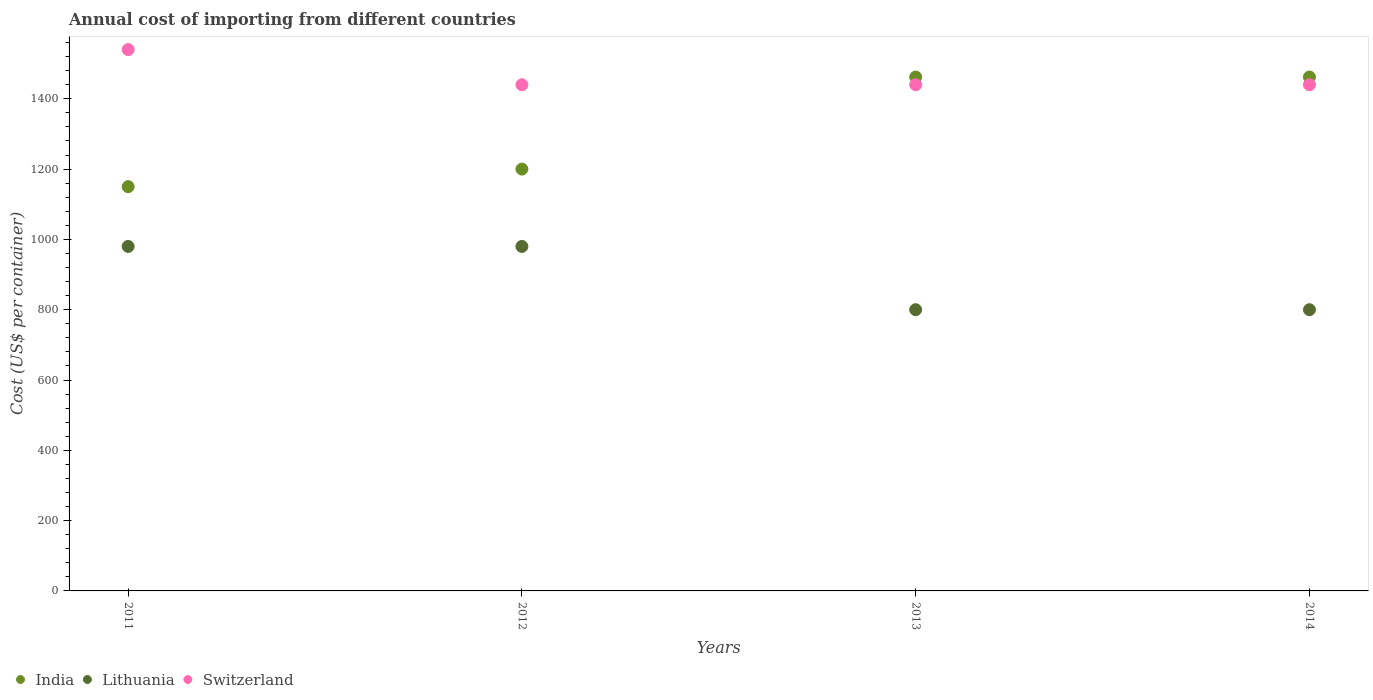How many different coloured dotlines are there?
Keep it short and to the point. 3. Is the number of dotlines equal to the number of legend labels?
Offer a very short reply. Yes. What is the total annual cost of importing in Switzerland in 2014?
Your answer should be compact. 1440. Across all years, what is the maximum total annual cost of importing in Switzerland?
Provide a succinct answer. 1540. Across all years, what is the minimum total annual cost of importing in Switzerland?
Make the answer very short. 1440. In which year was the total annual cost of importing in Switzerland minimum?
Your response must be concise. 2012. What is the total total annual cost of importing in India in the graph?
Make the answer very short. 5274. What is the difference between the total annual cost of importing in India in 2013 and that in 2014?
Provide a succinct answer. 0. What is the difference between the total annual cost of importing in Switzerland in 2011 and the total annual cost of importing in Lithuania in 2014?
Offer a terse response. 740. What is the average total annual cost of importing in Lithuania per year?
Your answer should be very brief. 890. In the year 2014, what is the difference between the total annual cost of importing in India and total annual cost of importing in Switzerland?
Offer a very short reply. 22. What is the ratio of the total annual cost of importing in Lithuania in 2013 to that in 2014?
Offer a terse response. 1. Is the total annual cost of importing in Switzerland in 2012 less than that in 2014?
Your answer should be very brief. No. Is the difference between the total annual cost of importing in India in 2011 and 2012 greater than the difference between the total annual cost of importing in Switzerland in 2011 and 2012?
Offer a terse response. No. What is the difference between the highest and the second highest total annual cost of importing in India?
Provide a succinct answer. 0. What is the difference between the highest and the lowest total annual cost of importing in Switzerland?
Make the answer very short. 100. Is the total annual cost of importing in Switzerland strictly less than the total annual cost of importing in Lithuania over the years?
Keep it short and to the point. No. How many dotlines are there?
Provide a short and direct response. 3. What is the difference between two consecutive major ticks on the Y-axis?
Provide a short and direct response. 200. Does the graph contain grids?
Offer a terse response. No. Where does the legend appear in the graph?
Your response must be concise. Bottom left. How are the legend labels stacked?
Offer a very short reply. Horizontal. What is the title of the graph?
Keep it short and to the point. Annual cost of importing from different countries. Does "Pakistan" appear as one of the legend labels in the graph?
Ensure brevity in your answer.  No. What is the label or title of the X-axis?
Your answer should be compact. Years. What is the label or title of the Y-axis?
Your answer should be very brief. Cost (US$ per container). What is the Cost (US$ per container) of India in 2011?
Give a very brief answer. 1150. What is the Cost (US$ per container) of Lithuania in 2011?
Your response must be concise. 980. What is the Cost (US$ per container) in Switzerland in 2011?
Your response must be concise. 1540. What is the Cost (US$ per container) in India in 2012?
Offer a terse response. 1200. What is the Cost (US$ per container) of Lithuania in 2012?
Offer a very short reply. 980. What is the Cost (US$ per container) of Switzerland in 2012?
Provide a short and direct response. 1440. What is the Cost (US$ per container) in India in 2013?
Your response must be concise. 1462. What is the Cost (US$ per container) in Lithuania in 2013?
Your answer should be very brief. 800. What is the Cost (US$ per container) of Switzerland in 2013?
Your answer should be compact. 1440. What is the Cost (US$ per container) of India in 2014?
Offer a terse response. 1462. What is the Cost (US$ per container) in Lithuania in 2014?
Give a very brief answer. 800. What is the Cost (US$ per container) in Switzerland in 2014?
Offer a very short reply. 1440. Across all years, what is the maximum Cost (US$ per container) of India?
Give a very brief answer. 1462. Across all years, what is the maximum Cost (US$ per container) in Lithuania?
Your response must be concise. 980. Across all years, what is the maximum Cost (US$ per container) in Switzerland?
Offer a terse response. 1540. Across all years, what is the minimum Cost (US$ per container) in India?
Provide a short and direct response. 1150. Across all years, what is the minimum Cost (US$ per container) in Lithuania?
Offer a very short reply. 800. Across all years, what is the minimum Cost (US$ per container) of Switzerland?
Your answer should be very brief. 1440. What is the total Cost (US$ per container) of India in the graph?
Your answer should be compact. 5274. What is the total Cost (US$ per container) of Lithuania in the graph?
Give a very brief answer. 3560. What is the total Cost (US$ per container) in Switzerland in the graph?
Your answer should be compact. 5860. What is the difference between the Cost (US$ per container) in Lithuania in 2011 and that in 2012?
Make the answer very short. 0. What is the difference between the Cost (US$ per container) of India in 2011 and that in 2013?
Your answer should be very brief. -312. What is the difference between the Cost (US$ per container) in Lithuania in 2011 and that in 2013?
Offer a very short reply. 180. What is the difference between the Cost (US$ per container) of India in 2011 and that in 2014?
Your answer should be compact. -312. What is the difference between the Cost (US$ per container) in Lithuania in 2011 and that in 2014?
Keep it short and to the point. 180. What is the difference between the Cost (US$ per container) in India in 2012 and that in 2013?
Your answer should be very brief. -262. What is the difference between the Cost (US$ per container) in Lithuania in 2012 and that in 2013?
Offer a very short reply. 180. What is the difference between the Cost (US$ per container) of Switzerland in 2012 and that in 2013?
Offer a very short reply. 0. What is the difference between the Cost (US$ per container) in India in 2012 and that in 2014?
Your answer should be compact. -262. What is the difference between the Cost (US$ per container) of Lithuania in 2012 and that in 2014?
Ensure brevity in your answer.  180. What is the difference between the Cost (US$ per container) in Switzerland in 2012 and that in 2014?
Your answer should be very brief. 0. What is the difference between the Cost (US$ per container) of India in 2013 and that in 2014?
Your answer should be very brief. 0. What is the difference between the Cost (US$ per container) of Switzerland in 2013 and that in 2014?
Ensure brevity in your answer.  0. What is the difference between the Cost (US$ per container) of India in 2011 and the Cost (US$ per container) of Lithuania in 2012?
Provide a short and direct response. 170. What is the difference between the Cost (US$ per container) in India in 2011 and the Cost (US$ per container) in Switzerland in 2012?
Give a very brief answer. -290. What is the difference between the Cost (US$ per container) in Lithuania in 2011 and the Cost (US$ per container) in Switzerland in 2012?
Offer a terse response. -460. What is the difference between the Cost (US$ per container) in India in 2011 and the Cost (US$ per container) in Lithuania in 2013?
Provide a short and direct response. 350. What is the difference between the Cost (US$ per container) of India in 2011 and the Cost (US$ per container) of Switzerland in 2013?
Provide a succinct answer. -290. What is the difference between the Cost (US$ per container) of Lithuania in 2011 and the Cost (US$ per container) of Switzerland in 2013?
Give a very brief answer. -460. What is the difference between the Cost (US$ per container) of India in 2011 and the Cost (US$ per container) of Lithuania in 2014?
Provide a short and direct response. 350. What is the difference between the Cost (US$ per container) in India in 2011 and the Cost (US$ per container) in Switzerland in 2014?
Offer a terse response. -290. What is the difference between the Cost (US$ per container) in Lithuania in 2011 and the Cost (US$ per container) in Switzerland in 2014?
Offer a terse response. -460. What is the difference between the Cost (US$ per container) in India in 2012 and the Cost (US$ per container) in Lithuania in 2013?
Your answer should be very brief. 400. What is the difference between the Cost (US$ per container) in India in 2012 and the Cost (US$ per container) in Switzerland in 2013?
Your answer should be compact. -240. What is the difference between the Cost (US$ per container) in Lithuania in 2012 and the Cost (US$ per container) in Switzerland in 2013?
Offer a very short reply. -460. What is the difference between the Cost (US$ per container) of India in 2012 and the Cost (US$ per container) of Switzerland in 2014?
Your answer should be compact. -240. What is the difference between the Cost (US$ per container) in Lithuania in 2012 and the Cost (US$ per container) in Switzerland in 2014?
Give a very brief answer. -460. What is the difference between the Cost (US$ per container) of India in 2013 and the Cost (US$ per container) of Lithuania in 2014?
Your answer should be compact. 662. What is the difference between the Cost (US$ per container) of Lithuania in 2013 and the Cost (US$ per container) of Switzerland in 2014?
Your response must be concise. -640. What is the average Cost (US$ per container) in India per year?
Keep it short and to the point. 1318.5. What is the average Cost (US$ per container) in Lithuania per year?
Your response must be concise. 890. What is the average Cost (US$ per container) of Switzerland per year?
Your response must be concise. 1465. In the year 2011, what is the difference between the Cost (US$ per container) in India and Cost (US$ per container) in Lithuania?
Make the answer very short. 170. In the year 2011, what is the difference between the Cost (US$ per container) in India and Cost (US$ per container) in Switzerland?
Your response must be concise. -390. In the year 2011, what is the difference between the Cost (US$ per container) of Lithuania and Cost (US$ per container) of Switzerland?
Your response must be concise. -560. In the year 2012, what is the difference between the Cost (US$ per container) of India and Cost (US$ per container) of Lithuania?
Offer a terse response. 220. In the year 2012, what is the difference between the Cost (US$ per container) of India and Cost (US$ per container) of Switzerland?
Provide a short and direct response. -240. In the year 2012, what is the difference between the Cost (US$ per container) of Lithuania and Cost (US$ per container) of Switzerland?
Give a very brief answer. -460. In the year 2013, what is the difference between the Cost (US$ per container) in India and Cost (US$ per container) in Lithuania?
Make the answer very short. 662. In the year 2013, what is the difference between the Cost (US$ per container) of Lithuania and Cost (US$ per container) of Switzerland?
Give a very brief answer. -640. In the year 2014, what is the difference between the Cost (US$ per container) of India and Cost (US$ per container) of Lithuania?
Your answer should be very brief. 662. In the year 2014, what is the difference between the Cost (US$ per container) of India and Cost (US$ per container) of Switzerland?
Provide a short and direct response. 22. In the year 2014, what is the difference between the Cost (US$ per container) in Lithuania and Cost (US$ per container) in Switzerland?
Keep it short and to the point. -640. What is the ratio of the Cost (US$ per container) of India in 2011 to that in 2012?
Your response must be concise. 0.96. What is the ratio of the Cost (US$ per container) in Switzerland in 2011 to that in 2012?
Your response must be concise. 1.07. What is the ratio of the Cost (US$ per container) of India in 2011 to that in 2013?
Your response must be concise. 0.79. What is the ratio of the Cost (US$ per container) of Lithuania in 2011 to that in 2013?
Your answer should be very brief. 1.23. What is the ratio of the Cost (US$ per container) of Switzerland in 2011 to that in 2013?
Give a very brief answer. 1.07. What is the ratio of the Cost (US$ per container) in India in 2011 to that in 2014?
Ensure brevity in your answer.  0.79. What is the ratio of the Cost (US$ per container) of Lithuania in 2011 to that in 2014?
Provide a succinct answer. 1.23. What is the ratio of the Cost (US$ per container) of Switzerland in 2011 to that in 2014?
Make the answer very short. 1.07. What is the ratio of the Cost (US$ per container) of India in 2012 to that in 2013?
Offer a very short reply. 0.82. What is the ratio of the Cost (US$ per container) in Lithuania in 2012 to that in 2013?
Offer a very short reply. 1.23. What is the ratio of the Cost (US$ per container) of India in 2012 to that in 2014?
Your answer should be very brief. 0.82. What is the ratio of the Cost (US$ per container) of Lithuania in 2012 to that in 2014?
Make the answer very short. 1.23. What is the ratio of the Cost (US$ per container) in Switzerland in 2012 to that in 2014?
Ensure brevity in your answer.  1. What is the ratio of the Cost (US$ per container) in Switzerland in 2013 to that in 2014?
Offer a terse response. 1. What is the difference between the highest and the second highest Cost (US$ per container) in Switzerland?
Ensure brevity in your answer.  100. What is the difference between the highest and the lowest Cost (US$ per container) of India?
Keep it short and to the point. 312. What is the difference between the highest and the lowest Cost (US$ per container) in Lithuania?
Provide a short and direct response. 180. 